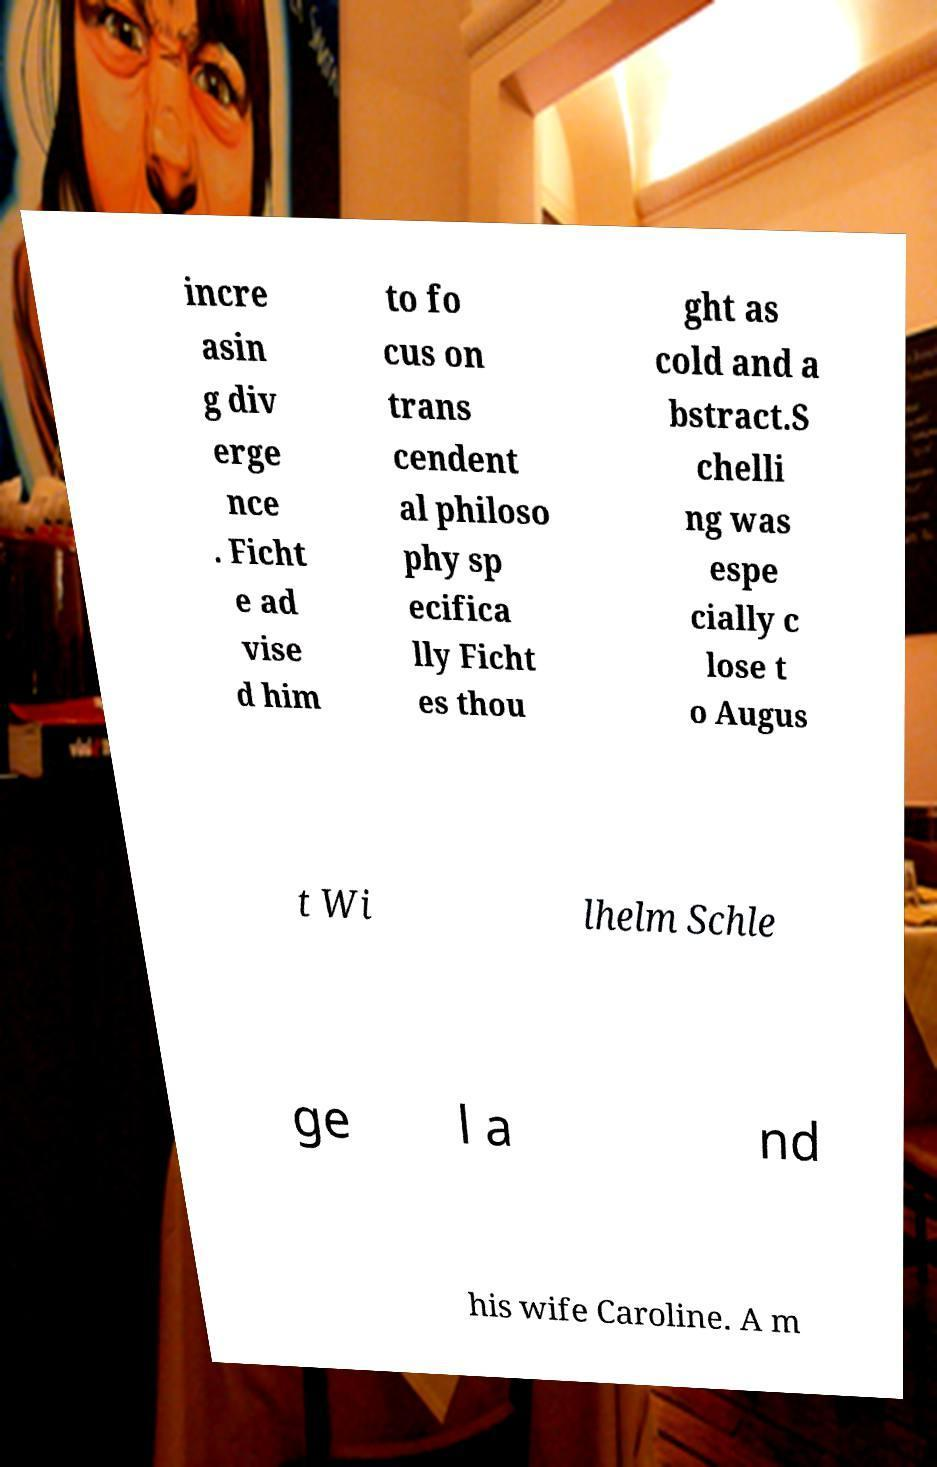Could you assist in decoding the text presented in this image and type it out clearly? incre asin g div erge nce . Ficht e ad vise d him to fo cus on trans cendent al philoso phy sp ecifica lly Ficht es thou ght as cold and a bstract.S chelli ng was espe cially c lose t o Augus t Wi lhelm Schle ge l a nd his wife Caroline. A m 